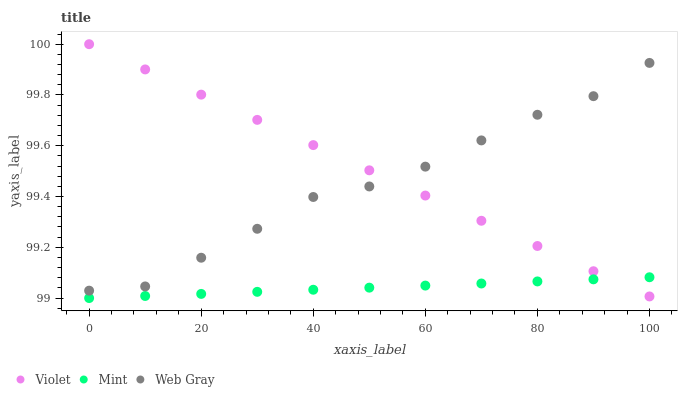Does Mint have the minimum area under the curve?
Answer yes or no. Yes. Does Violet have the maximum area under the curve?
Answer yes or no. Yes. Does Violet have the minimum area under the curve?
Answer yes or no. No. Does Mint have the maximum area under the curve?
Answer yes or no. No. Is Violet the smoothest?
Answer yes or no. Yes. Is Web Gray the roughest?
Answer yes or no. Yes. Is Mint the smoothest?
Answer yes or no. No. Is Mint the roughest?
Answer yes or no. No. Does Mint have the lowest value?
Answer yes or no. Yes. Does Violet have the lowest value?
Answer yes or no. No. Does Violet have the highest value?
Answer yes or no. Yes. Does Mint have the highest value?
Answer yes or no. No. Is Mint less than Web Gray?
Answer yes or no. Yes. Is Web Gray greater than Mint?
Answer yes or no. Yes. Does Violet intersect Web Gray?
Answer yes or no. Yes. Is Violet less than Web Gray?
Answer yes or no. No. Is Violet greater than Web Gray?
Answer yes or no. No. Does Mint intersect Web Gray?
Answer yes or no. No. 